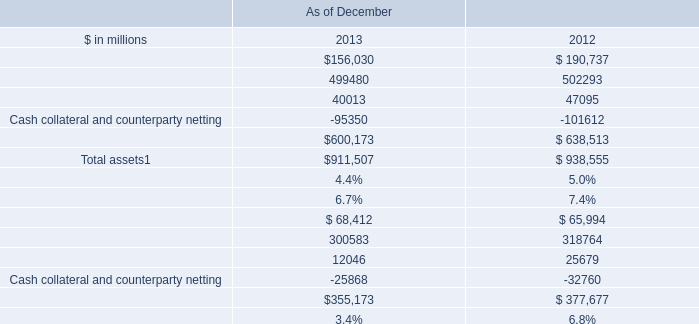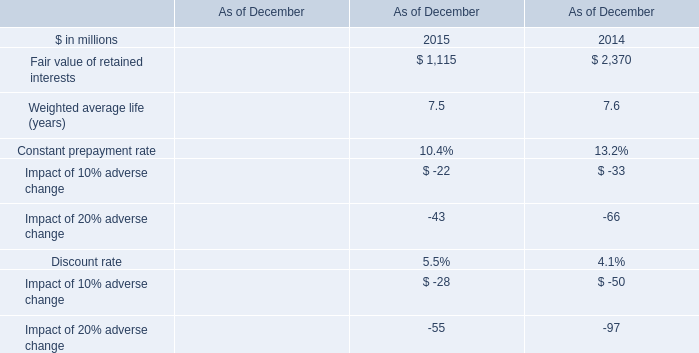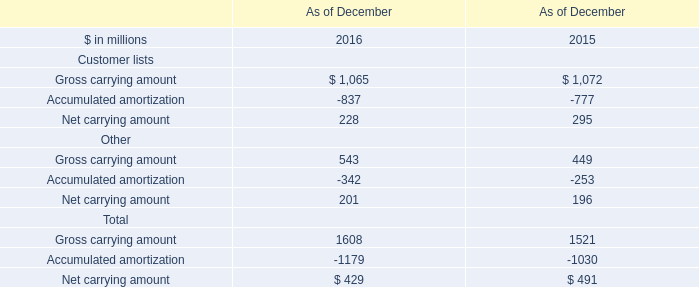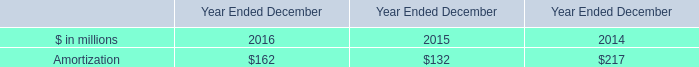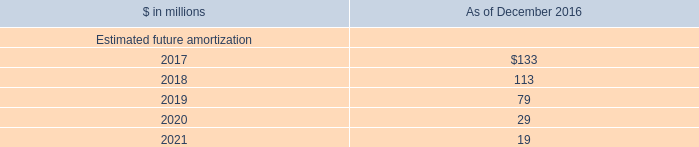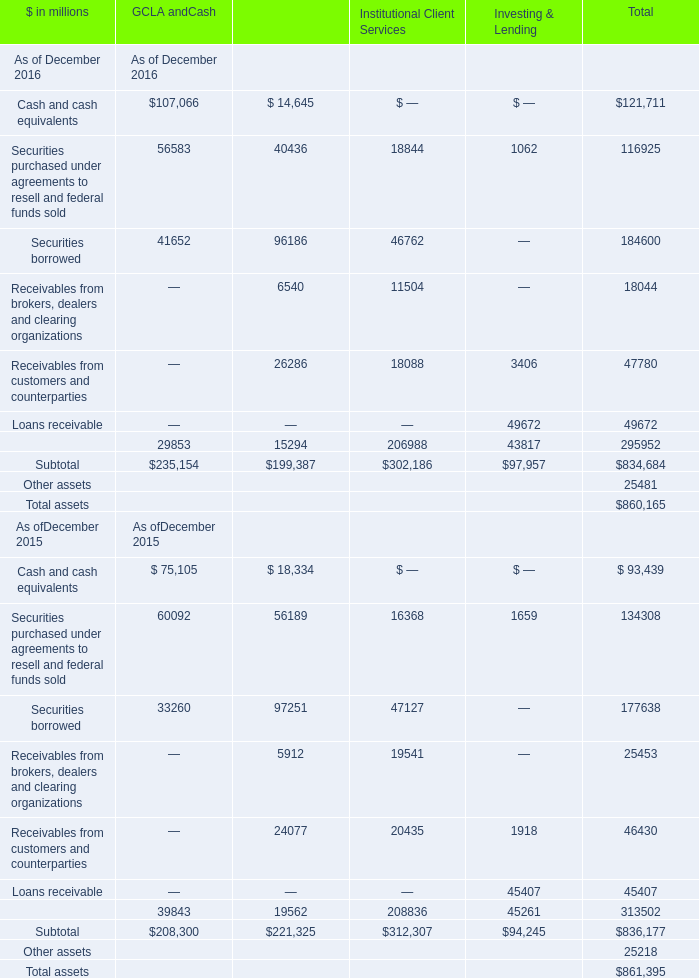What's the total amount of the Gross carrying amount and Accumulated amortization in the years where Amortization is less than 162 (in million) 
Computations: (1072 - 777)
Answer: 295.0. 